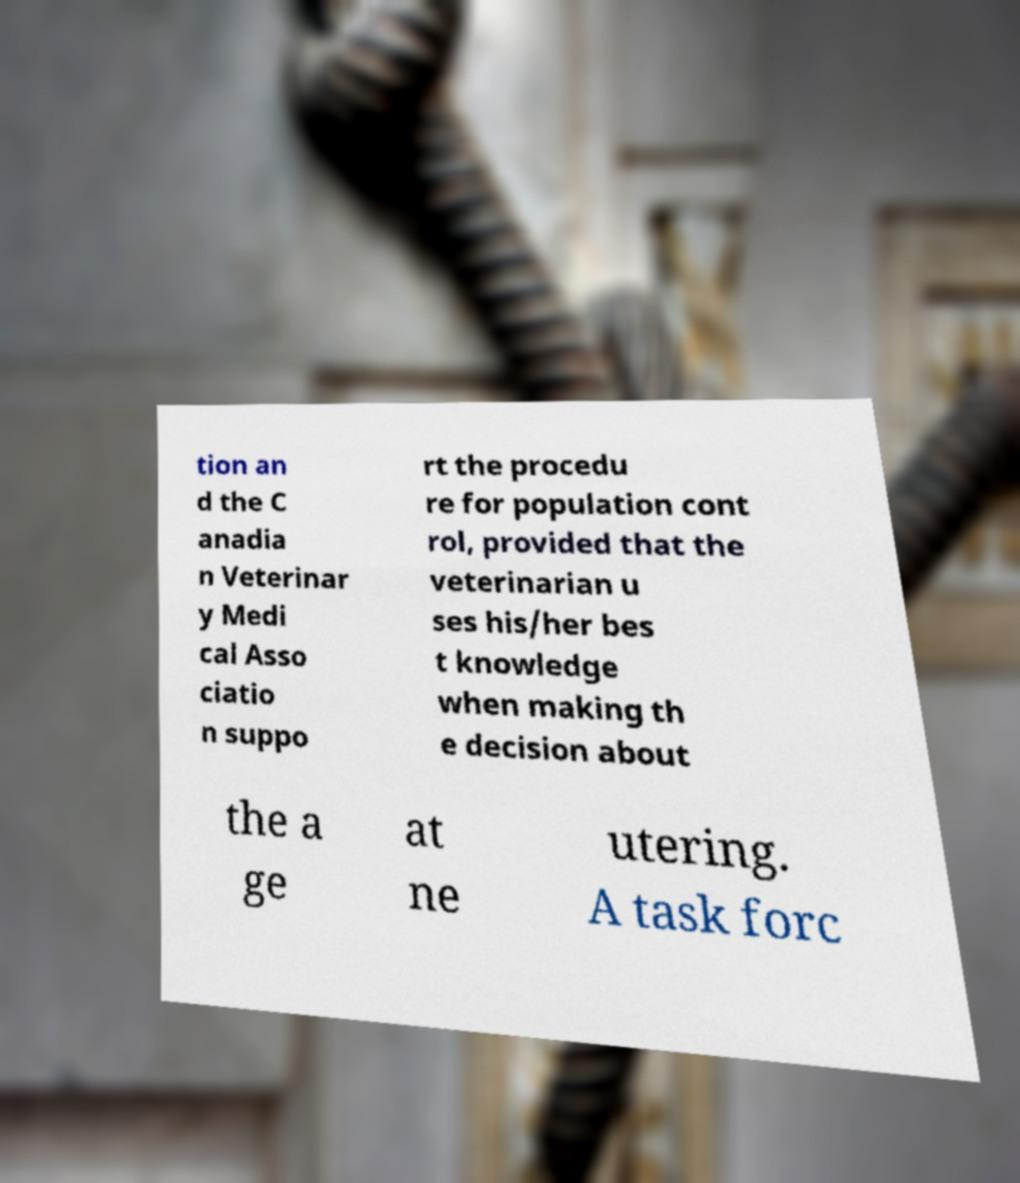For documentation purposes, I need the text within this image transcribed. Could you provide that? tion an d the C anadia n Veterinar y Medi cal Asso ciatio n suppo rt the procedu re for population cont rol, provided that the veterinarian u ses his/her bes t knowledge when making th e decision about the a ge at ne utering. A task forc 